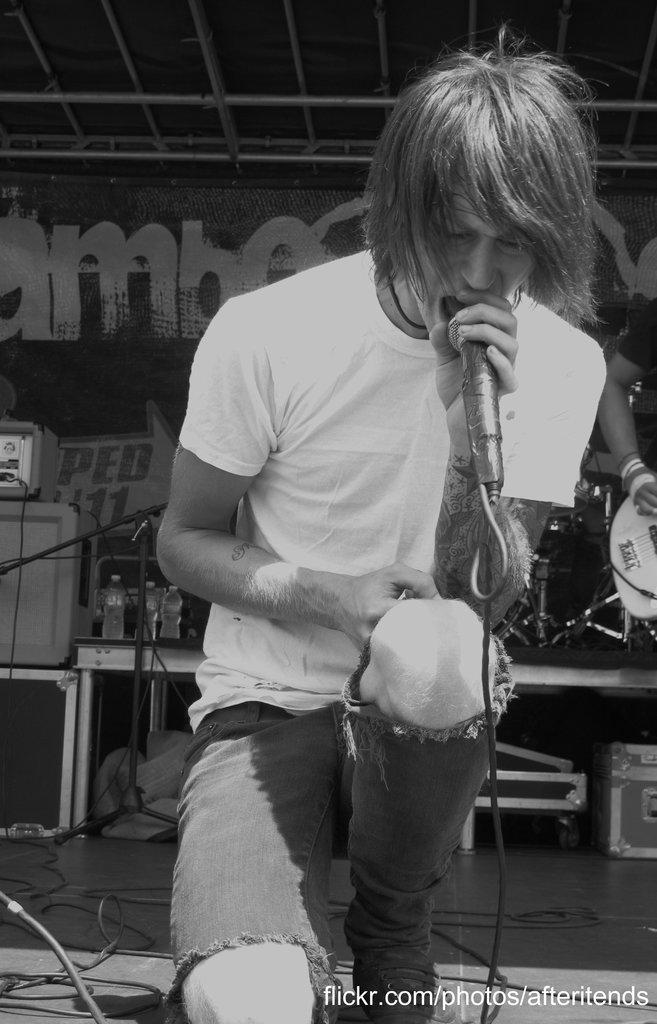What is the person in the image holding? The person in the image is holding a mic. What can be seen in the background of the image? There are musical instruments in the background of the image. What are the rods visible at the top of the image used for? The purpose of the rods visible at the top of the image is not specified, but they could be part of a stage or lighting setup. What type of cloth is draped over the tripod in the image? There is no tripod or cloth present in the image. 